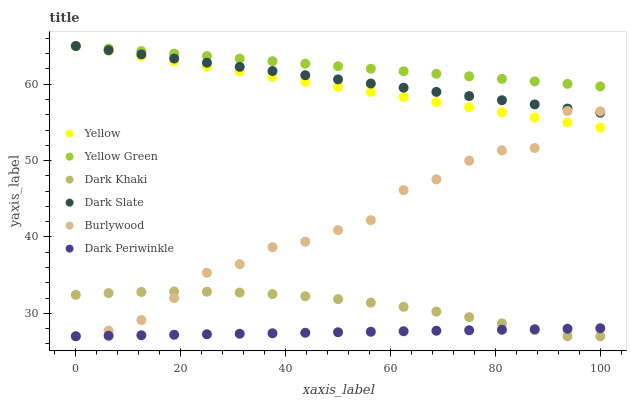Does Dark Periwinkle have the minimum area under the curve?
Answer yes or no. Yes. Does Yellow Green have the maximum area under the curve?
Answer yes or no. Yes. Does Burlywood have the minimum area under the curve?
Answer yes or no. No. Does Burlywood have the maximum area under the curve?
Answer yes or no. No. Is Dark Periwinkle the smoothest?
Answer yes or no. Yes. Is Burlywood the roughest?
Answer yes or no. Yes. Is Yellow the smoothest?
Answer yes or no. No. Is Yellow the roughest?
Answer yes or no. No. Does Burlywood have the lowest value?
Answer yes or no. Yes. Does Yellow have the lowest value?
Answer yes or no. No. Does Dark Slate have the highest value?
Answer yes or no. Yes. Does Burlywood have the highest value?
Answer yes or no. No. Is Burlywood less than Yellow Green?
Answer yes or no. Yes. Is Yellow greater than Dark Khaki?
Answer yes or no. Yes. Does Yellow intersect Yellow Green?
Answer yes or no. Yes. Is Yellow less than Yellow Green?
Answer yes or no. No. Is Yellow greater than Yellow Green?
Answer yes or no. No. Does Burlywood intersect Yellow Green?
Answer yes or no. No. 